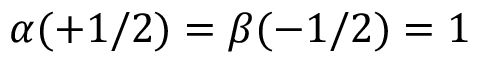<formula> <loc_0><loc_0><loc_500><loc_500>\alpha ( + 1 / 2 ) = \beta ( - 1 / 2 ) = 1</formula> 